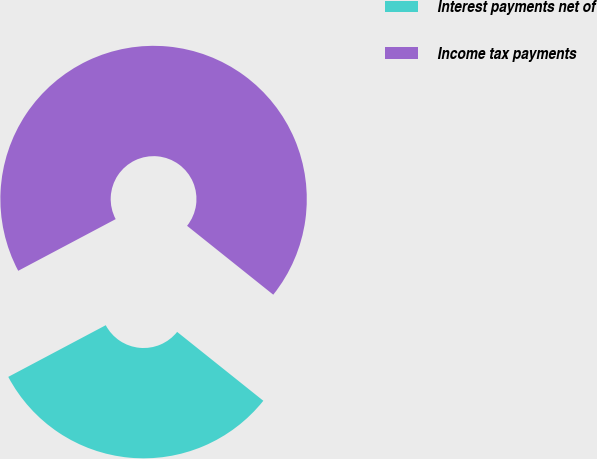<chart> <loc_0><loc_0><loc_500><loc_500><pie_chart><fcel>Interest payments net of<fcel>Income tax payments<nl><fcel>31.51%<fcel>68.49%<nl></chart> 